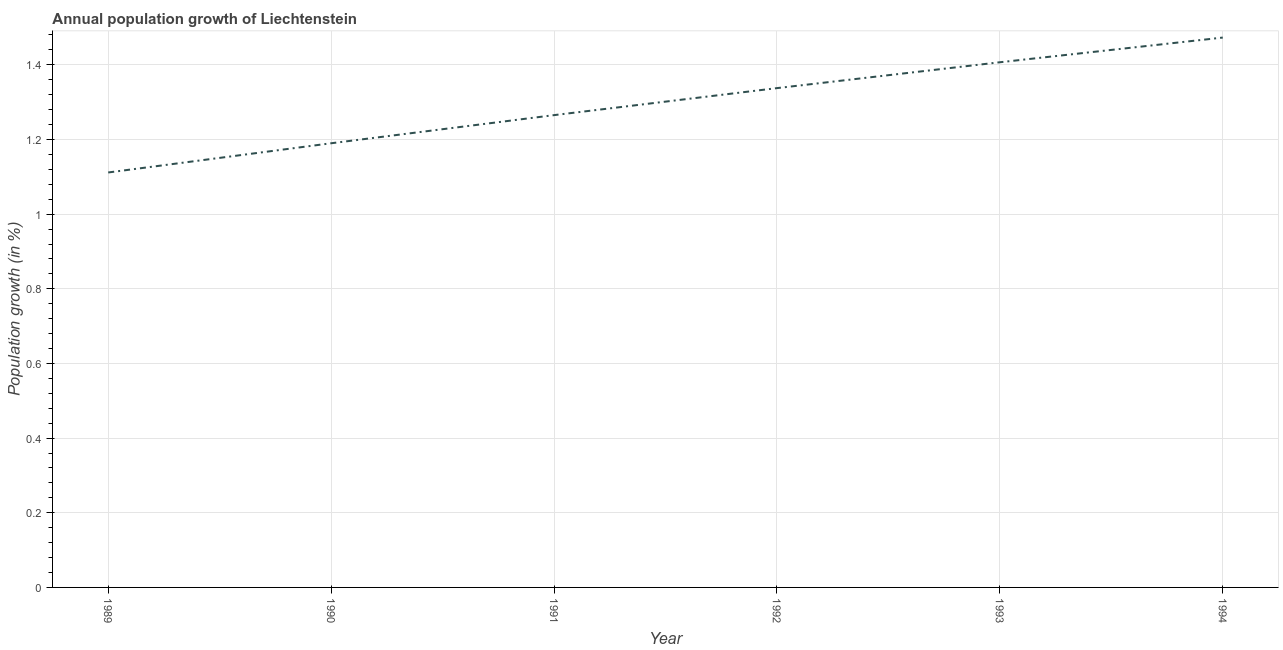What is the population growth in 1990?
Give a very brief answer. 1.19. Across all years, what is the maximum population growth?
Provide a succinct answer. 1.47. Across all years, what is the minimum population growth?
Make the answer very short. 1.11. In which year was the population growth maximum?
Keep it short and to the point. 1994. What is the sum of the population growth?
Offer a terse response. 7.78. What is the difference between the population growth in 1989 and 1992?
Offer a very short reply. -0.23. What is the average population growth per year?
Provide a short and direct response. 1.3. What is the median population growth?
Your answer should be compact. 1.3. In how many years, is the population growth greater than 0.6400000000000001 %?
Your answer should be compact. 6. Do a majority of the years between 1994 and 1991 (inclusive) have population growth greater than 0.9600000000000001 %?
Offer a very short reply. Yes. What is the ratio of the population growth in 1990 to that in 1993?
Keep it short and to the point. 0.85. Is the population growth in 1991 less than that in 1993?
Provide a succinct answer. Yes. Is the difference between the population growth in 1989 and 1992 greater than the difference between any two years?
Offer a very short reply. No. What is the difference between the highest and the second highest population growth?
Your answer should be compact. 0.07. Is the sum of the population growth in 1989 and 1993 greater than the maximum population growth across all years?
Your response must be concise. Yes. What is the difference between the highest and the lowest population growth?
Your answer should be very brief. 0.36. In how many years, is the population growth greater than the average population growth taken over all years?
Offer a very short reply. 3. Does the graph contain any zero values?
Offer a terse response. No. What is the title of the graph?
Offer a very short reply. Annual population growth of Liechtenstein. What is the label or title of the X-axis?
Keep it short and to the point. Year. What is the label or title of the Y-axis?
Your response must be concise. Population growth (in %). What is the Population growth (in %) of 1989?
Your answer should be very brief. 1.11. What is the Population growth (in %) in 1990?
Offer a very short reply. 1.19. What is the Population growth (in %) in 1991?
Ensure brevity in your answer.  1.27. What is the Population growth (in %) of 1992?
Your answer should be very brief. 1.34. What is the Population growth (in %) in 1993?
Make the answer very short. 1.41. What is the Population growth (in %) in 1994?
Your answer should be compact. 1.47. What is the difference between the Population growth (in %) in 1989 and 1990?
Provide a succinct answer. -0.08. What is the difference between the Population growth (in %) in 1989 and 1991?
Give a very brief answer. -0.15. What is the difference between the Population growth (in %) in 1989 and 1992?
Provide a succinct answer. -0.23. What is the difference between the Population growth (in %) in 1989 and 1993?
Your answer should be very brief. -0.3. What is the difference between the Population growth (in %) in 1989 and 1994?
Your answer should be very brief. -0.36. What is the difference between the Population growth (in %) in 1990 and 1991?
Offer a terse response. -0.08. What is the difference between the Population growth (in %) in 1990 and 1992?
Keep it short and to the point. -0.15. What is the difference between the Population growth (in %) in 1990 and 1993?
Make the answer very short. -0.22. What is the difference between the Population growth (in %) in 1990 and 1994?
Keep it short and to the point. -0.28. What is the difference between the Population growth (in %) in 1991 and 1992?
Offer a terse response. -0.07. What is the difference between the Population growth (in %) in 1991 and 1993?
Provide a succinct answer. -0.14. What is the difference between the Population growth (in %) in 1991 and 1994?
Offer a terse response. -0.21. What is the difference between the Population growth (in %) in 1992 and 1993?
Offer a very short reply. -0.07. What is the difference between the Population growth (in %) in 1992 and 1994?
Your answer should be very brief. -0.14. What is the difference between the Population growth (in %) in 1993 and 1994?
Offer a terse response. -0.07. What is the ratio of the Population growth (in %) in 1989 to that in 1990?
Provide a short and direct response. 0.93. What is the ratio of the Population growth (in %) in 1989 to that in 1991?
Keep it short and to the point. 0.88. What is the ratio of the Population growth (in %) in 1989 to that in 1992?
Keep it short and to the point. 0.83. What is the ratio of the Population growth (in %) in 1989 to that in 1993?
Make the answer very short. 0.79. What is the ratio of the Population growth (in %) in 1989 to that in 1994?
Keep it short and to the point. 0.76. What is the ratio of the Population growth (in %) in 1990 to that in 1992?
Provide a succinct answer. 0.89. What is the ratio of the Population growth (in %) in 1990 to that in 1993?
Keep it short and to the point. 0.85. What is the ratio of the Population growth (in %) in 1990 to that in 1994?
Provide a short and direct response. 0.81. What is the ratio of the Population growth (in %) in 1991 to that in 1992?
Offer a very short reply. 0.95. What is the ratio of the Population growth (in %) in 1991 to that in 1993?
Offer a terse response. 0.9. What is the ratio of the Population growth (in %) in 1991 to that in 1994?
Offer a terse response. 0.86. What is the ratio of the Population growth (in %) in 1992 to that in 1993?
Provide a succinct answer. 0.95. What is the ratio of the Population growth (in %) in 1992 to that in 1994?
Make the answer very short. 0.91. What is the ratio of the Population growth (in %) in 1993 to that in 1994?
Your response must be concise. 0.95. 